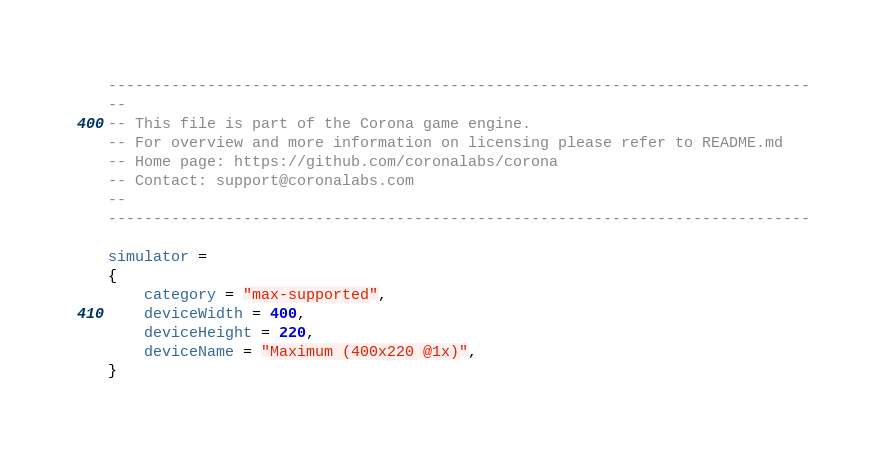Convert code to text. <code><loc_0><loc_0><loc_500><loc_500><_Lua_>------------------------------------------------------------------------------
--
-- This file is part of the Corona game engine.
-- For overview and more information on licensing please refer to README.md 
-- Home page: https://github.com/coronalabs/corona
-- Contact: support@coronalabs.com
--
------------------------------------------------------------------------------

simulator =
{
	category = "max-supported",
	deviceWidth = 400,
	deviceHeight = 220,
	deviceName = "Maximum (400x220 @1x)",
}
</code> 